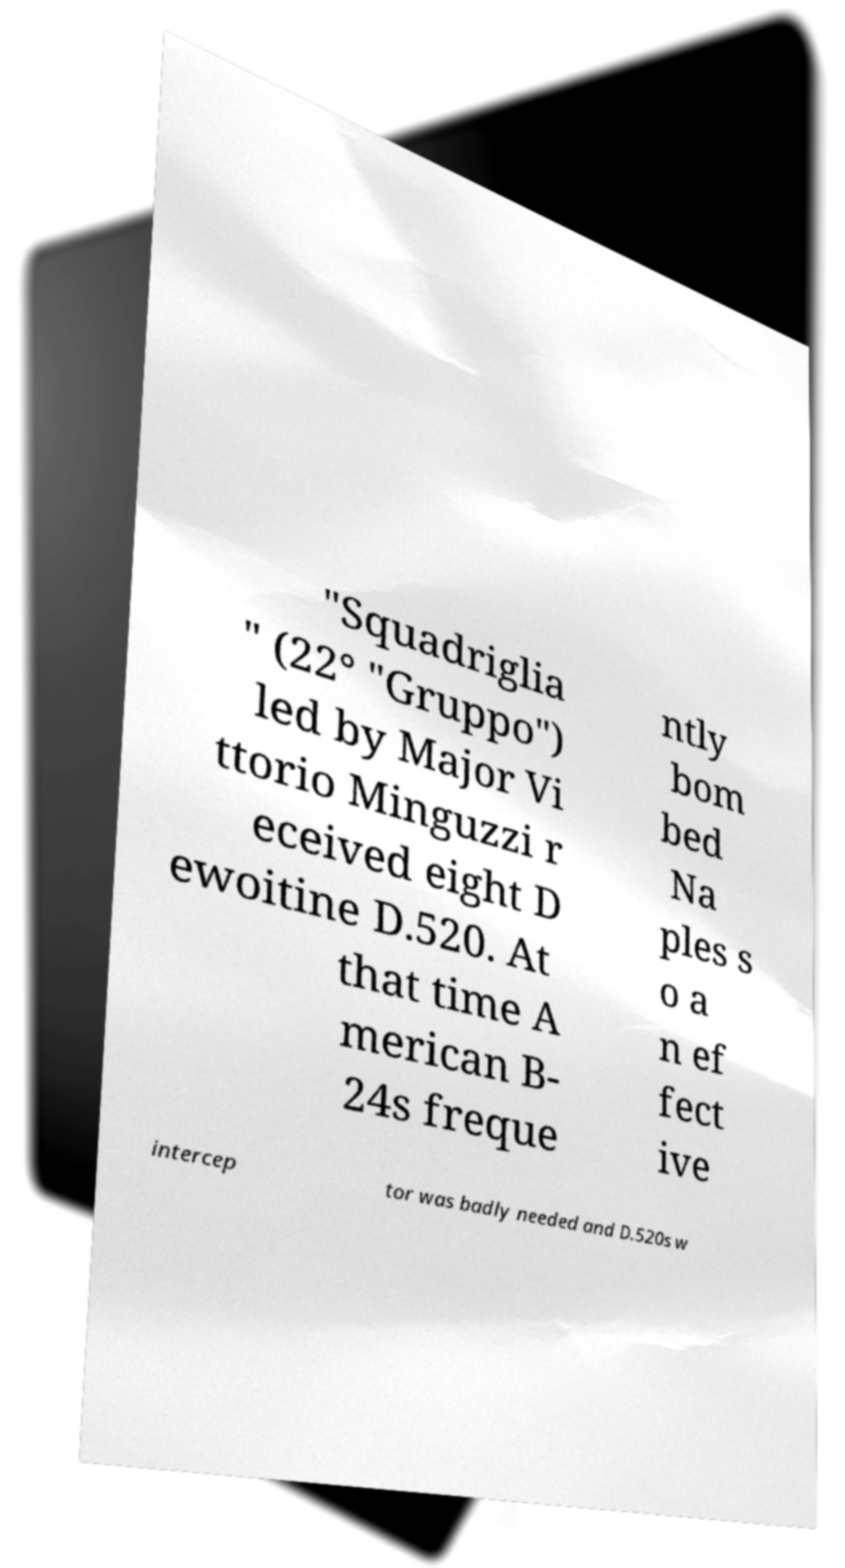There's text embedded in this image that I need extracted. Can you transcribe it verbatim? "Squadriglia " (22° "Gruppo") led by Major Vi ttorio Minguzzi r eceived eight D ewoitine D.520. At that time A merican B- 24s freque ntly bom bed Na ples s o a n ef fect ive intercep tor was badly needed and D.520s w 